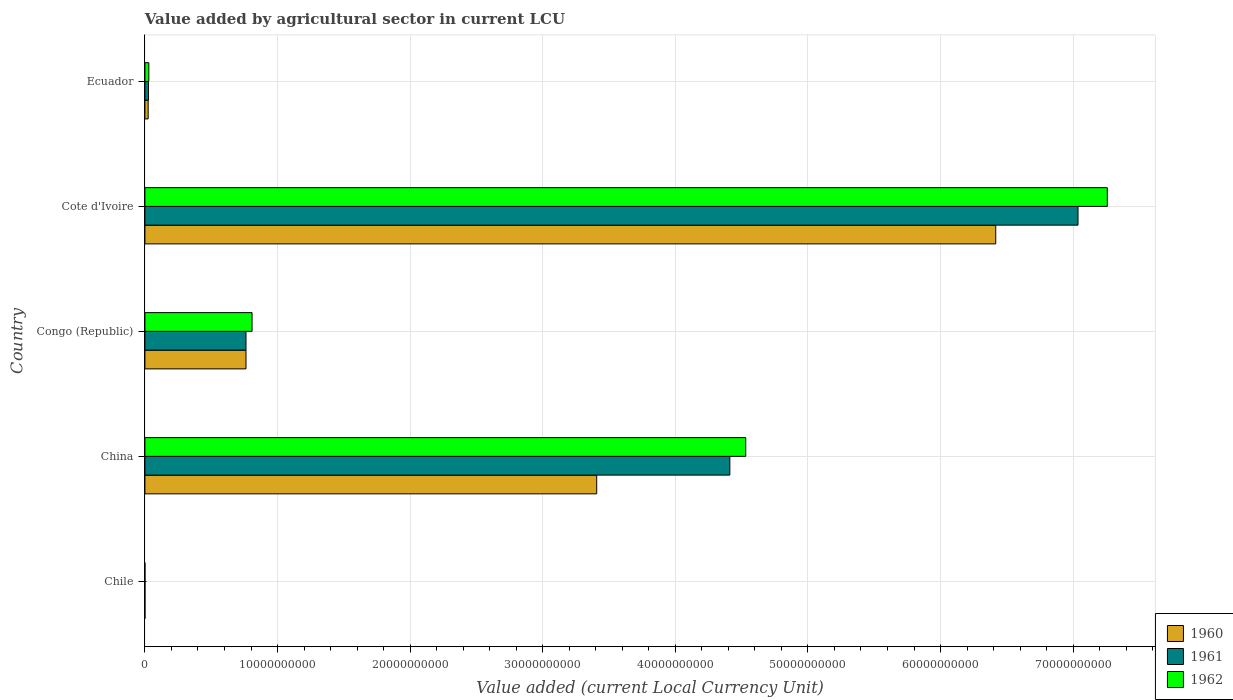How many groups of bars are there?
Your response must be concise. 5. Are the number of bars per tick equal to the number of legend labels?
Provide a short and direct response. Yes. Are the number of bars on each tick of the Y-axis equal?
Provide a short and direct response. Yes. How many bars are there on the 1st tick from the bottom?
Offer a terse response. 3. What is the label of the 2nd group of bars from the top?
Your answer should be very brief. Cote d'Ivoire. In how many cases, is the number of bars for a given country not equal to the number of legend labels?
Your response must be concise. 0. What is the value added by agricultural sector in 1962 in Cote d'Ivoire?
Your answer should be compact. 7.26e+1. Across all countries, what is the maximum value added by agricultural sector in 1961?
Your response must be concise. 7.04e+1. Across all countries, what is the minimum value added by agricultural sector in 1961?
Give a very brief answer. 5.00e+05. In which country was the value added by agricultural sector in 1961 maximum?
Provide a succinct answer. Cote d'Ivoire. What is the total value added by agricultural sector in 1962 in the graph?
Provide a short and direct response. 1.26e+11. What is the difference between the value added by agricultural sector in 1961 in Chile and that in China?
Make the answer very short. -4.41e+1. What is the difference between the value added by agricultural sector in 1961 in China and the value added by agricultural sector in 1960 in Congo (Republic)?
Your answer should be very brief. 3.65e+1. What is the average value added by agricultural sector in 1961 per country?
Provide a short and direct response. 2.45e+1. What is the difference between the value added by agricultural sector in 1961 and value added by agricultural sector in 1962 in China?
Ensure brevity in your answer.  -1.20e+09. What is the ratio of the value added by agricultural sector in 1960 in Chile to that in China?
Ensure brevity in your answer.  1.1740534194305841e-5. Is the value added by agricultural sector in 1962 in Cote d'Ivoire less than that in Ecuador?
Keep it short and to the point. No. Is the difference between the value added by agricultural sector in 1961 in Congo (Republic) and Ecuador greater than the difference between the value added by agricultural sector in 1962 in Congo (Republic) and Ecuador?
Your answer should be very brief. No. What is the difference between the highest and the second highest value added by agricultural sector in 1962?
Keep it short and to the point. 2.73e+1. What is the difference between the highest and the lowest value added by agricultural sector in 1962?
Offer a very short reply. 7.26e+1. Are all the bars in the graph horizontal?
Offer a terse response. Yes. How many countries are there in the graph?
Your response must be concise. 5. Are the values on the major ticks of X-axis written in scientific E-notation?
Provide a short and direct response. No. What is the title of the graph?
Your answer should be compact. Value added by agricultural sector in current LCU. Does "1998" appear as one of the legend labels in the graph?
Provide a succinct answer. No. What is the label or title of the X-axis?
Keep it short and to the point. Value added (current Local Currency Unit). What is the Value added (current Local Currency Unit) of 1960 in Chile?
Your answer should be very brief. 4.00e+05. What is the Value added (current Local Currency Unit) of 1962 in Chile?
Your answer should be very brief. 5.00e+05. What is the Value added (current Local Currency Unit) of 1960 in China?
Give a very brief answer. 3.41e+1. What is the Value added (current Local Currency Unit) in 1961 in China?
Keep it short and to the point. 4.41e+1. What is the Value added (current Local Currency Unit) of 1962 in China?
Make the answer very short. 4.53e+1. What is the Value added (current Local Currency Unit) of 1960 in Congo (Republic)?
Ensure brevity in your answer.  7.62e+09. What is the Value added (current Local Currency Unit) in 1961 in Congo (Republic)?
Your answer should be compact. 7.62e+09. What is the Value added (current Local Currency Unit) in 1962 in Congo (Republic)?
Keep it short and to the point. 8.08e+09. What is the Value added (current Local Currency Unit) in 1960 in Cote d'Ivoire?
Make the answer very short. 6.42e+1. What is the Value added (current Local Currency Unit) in 1961 in Cote d'Ivoire?
Provide a succinct answer. 7.04e+1. What is the Value added (current Local Currency Unit) in 1962 in Cote d'Ivoire?
Your answer should be compact. 7.26e+1. What is the Value added (current Local Currency Unit) of 1960 in Ecuador?
Keep it short and to the point. 2.45e+08. What is the Value added (current Local Currency Unit) of 1961 in Ecuador?
Offer a terse response. 2.66e+08. What is the Value added (current Local Currency Unit) in 1962 in Ecuador?
Offer a very short reply. 2.95e+08. Across all countries, what is the maximum Value added (current Local Currency Unit) of 1960?
Offer a terse response. 6.42e+1. Across all countries, what is the maximum Value added (current Local Currency Unit) in 1961?
Make the answer very short. 7.04e+1. Across all countries, what is the maximum Value added (current Local Currency Unit) in 1962?
Make the answer very short. 7.26e+1. Across all countries, what is the minimum Value added (current Local Currency Unit) in 1960?
Ensure brevity in your answer.  4.00e+05. What is the total Value added (current Local Currency Unit) in 1960 in the graph?
Provide a short and direct response. 1.06e+11. What is the total Value added (current Local Currency Unit) in 1961 in the graph?
Make the answer very short. 1.22e+11. What is the total Value added (current Local Currency Unit) in 1962 in the graph?
Your answer should be compact. 1.26e+11. What is the difference between the Value added (current Local Currency Unit) in 1960 in Chile and that in China?
Offer a terse response. -3.41e+1. What is the difference between the Value added (current Local Currency Unit) in 1961 in Chile and that in China?
Your answer should be very brief. -4.41e+1. What is the difference between the Value added (current Local Currency Unit) in 1962 in Chile and that in China?
Offer a terse response. -4.53e+1. What is the difference between the Value added (current Local Currency Unit) of 1960 in Chile and that in Congo (Republic)?
Give a very brief answer. -7.62e+09. What is the difference between the Value added (current Local Currency Unit) of 1961 in Chile and that in Congo (Republic)?
Offer a terse response. -7.62e+09. What is the difference between the Value added (current Local Currency Unit) of 1962 in Chile and that in Congo (Republic)?
Your answer should be very brief. -8.08e+09. What is the difference between the Value added (current Local Currency Unit) of 1960 in Chile and that in Cote d'Ivoire?
Make the answer very short. -6.42e+1. What is the difference between the Value added (current Local Currency Unit) in 1961 in Chile and that in Cote d'Ivoire?
Provide a succinct answer. -7.04e+1. What is the difference between the Value added (current Local Currency Unit) in 1962 in Chile and that in Cote d'Ivoire?
Your answer should be very brief. -7.26e+1. What is the difference between the Value added (current Local Currency Unit) in 1960 in Chile and that in Ecuador?
Provide a succinct answer. -2.45e+08. What is the difference between the Value added (current Local Currency Unit) of 1961 in Chile and that in Ecuador?
Make the answer very short. -2.66e+08. What is the difference between the Value added (current Local Currency Unit) of 1962 in Chile and that in Ecuador?
Ensure brevity in your answer.  -2.95e+08. What is the difference between the Value added (current Local Currency Unit) in 1960 in China and that in Congo (Republic)?
Provide a succinct answer. 2.64e+1. What is the difference between the Value added (current Local Currency Unit) of 1961 in China and that in Congo (Republic)?
Offer a terse response. 3.65e+1. What is the difference between the Value added (current Local Currency Unit) in 1962 in China and that in Congo (Republic)?
Your response must be concise. 3.72e+1. What is the difference between the Value added (current Local Currency Unit) in 1960 in China and that in Cote d'Ivoire?
Ensure brevity in your answer.  -3.01e+1. What is the difference between the Value added (current Local Currency Unit) of 1961 in China and that in Cote d'Ivoire?
Provide a short and direct response. -2.63e+1. What is the difference between the Value added (current Local Currency Unit) in 1962 in China and that in Cote d'Ivoire?
Your answer should be very brief. -2.73e+1. What is the difference between the Value added (current Local Currency Unit) of 1960 in China and that in Ecuador?
Provide a short and direct response. 3.38e+1. What is the difference between the Value added (current Local Currency Unit) in 1961 in China and that in Ecuador?
Make the answer very short. 4.38e+1. What is the difference between the Value added (current Local Currency Unit) in 1962 in China and that in Ecuador?
Provide a short and direct response. 4.50e+1. What is the difference between the Value added (current Local Currency Unit) in 1960 in Congo (Republic) and that in Cote d'Ivoire?
Your answer should be very brief. -5.65e+1. What is the difference between the Value added (current Local Currency Unit) in 1961 in Congo (Republic) and that in Cote d'Ivoire?
Offer a very short reply. -6.27e+1. What is the difference between the Value added (current Local Currency Unit) in 1962 in Congo (Republic) and that in Cote d'Ivoire?
Offer a terse response. -6.45e+1. What is the difference between the Value added (current Local Currency Unit) in 1960 in Congo (Republic) and that in Ecuador?
Provide a short and direct response. 7.38e+09. What is the difference between the Value added (current Local Currency Unit) in 1961 in Congo (Republic) and that in Ecuador?
Ensure brevity in your answer.  7.36e+09. What is the difference between the Value added (current Local Currency Unit) in 1962 in Congo (Republic) and that in Ecuador?
Provide a succinct answer. 7.79e+09. What is the difference between the Value added (current Local Currency Unit) of 1960 in Cote d'Ivoire and that in Ecuador?
Keep it short and to the point. 6.39e+1. What is the difference between the Value added (current Local Currency Unit) of 1961 in Cote d'Ivoire and that in Ecuador?
Make the answer very short. 7.01e+1. What is the difference between the Value added (current Local Currency Unit) in 1962 in Cote d'Ivoire and that in Ecuador?
Provide a succinct answer. 7.23e+1. What is the difference between the Value added (current Local Currency Unit) in 1960 in Chile and the Value added (current Local Currency Unit) in 1961 in China?
Provide a short and direct response. -4.41e+1. What is the difference between the Value added (current Local Currency Unit) of 1960 in Chile and the Value added (current Local Currency Unit) of 1962 in China?
Your answer should be compact. -4.53e+1. What is the difference between the Value added (current Local Currency Unit) of 1961 in Chile and the Value added (current Local Currency Unit) of 1962 in China?
Offer a terse response. -4.53e+1. What is the difference between the Value added (current Local Currency Unit) of 1960 in Chile and the Value added (current Local Currency Unit) of 1961 in Congo (Republic)?
Give a very brief answer. -7.62e+09. What is the difference between the Value added (current Local Currency Unit) of 1960 in Chile and the Value added (current Local Currency Unit) of 1962 in Congo (Republic)?
Keep it short and to the point. -8.08e+09. What is the difference between the Value added (current Local Currency Unit) in 1961 in Chile and the Value added (current Local Currency Unit) in 1962 in Congo (Republic)?
Ensure brevity in your answer.  -8.08e+09. What is the difference between the Value added (current Local Currency Unit) of 1960 in Chile and the Value added (current Local Currency Unit) of 1961 in Cote d'Ivoire?
Ensure brevity in your answer.  -7.04e+1. What is the difference between the Value added (current Local Currency Unit) in 1960 in Chile and the Value added (current Local Currency Unit) in 1962 in Cote d'Ivoire?
Ensure brevity in your answer.  -7.26e+1. What is the difference between the Value added (current Local Currency Unit) in 1961 in Chile and the Value added (current Local Currency Unit) in 1962 in Cote d'Ivoire?
Make the answer very short. -7.26e+1. What is the difference between the Value added (current Local Currency Unit) in 1960 in Chile and the Value added (current Local Currency Unit) in 1961 in Ecuador?
Your answer should be very brief. -2.66e+08. What is the difference between the Value added (current Local Currency Unit) of 1960 in Chile and the Value added (current Local Currency Unit) of 1962 in Ecuador?
Offer a terse response. -2.95e+08. What is the difference between the Value added (current Local Currency Unit) in 1961 in Chile and the Value added (current Local Currency Unit) in 1962 in Ecuador?
Keep it short and to the point. -2.95e+08. What is the difference between the Value added (current Local Currency Unit) of 1960 in China and the Value added (current Local Currency Unit) of 1961 in Congo (Republic)?
Your answer should be compact. 2.64e+1. What is the difference between the Value added (current Local Currency Unit) in 1960 in China and the Value added (current Local Currency Unit) in 1962 in Congo (Republic)?
Provide a short and direct response. 2.60e+1. What is the difference between the Value added (current Local Currency Unit) in 1961 in China and the Value added (current Local Currency Unit) in 1962 in Congo (Republic)?
Offer a terse response. 3.60e+1. What is the difference between the Value added (current Local Currency Unit) in 1960 in China and the Value added (current Local Currency Unit) in 1961 in Cote d'Ivoire?
Ensure brevity in your answer.  -3.63e+1. What is the difference between the Value added (current Local Currency Unit) in 1960 in China and the Value added (current Local Currency Unit) in 1962 in Cote d'Ivoire?
Give a very brief answer. -3.85e+1. What is the difference between the Value added (current Local Currency Unit) of 1961 in China and the Value added (current Local Currency Unit) of 1962 in Cote d'Ivoire?
Offer a terse response. -2.85e+1. What is the difference between the Value added (current Local Currency Unit) of 1960 in China and the Value added (current Local Currency Unit) of 1961 in Ecuador?
Keep it short and to the point. 3.38e+1. What is the difference between the Value added (current Local Currency Unit) in 1960 in China and the Value added (current Local Currency Unit) in 1962 in Ecuador?
Keep it short and to the point. 3.38e+1. What is the difference between the Value added (current Local Currency Unit) of 1961 in China and the Value added (current Local Currency Unit) of 1962 in Ecuador?
Provide a succinct answer. 4.38e+1. What is the difference between the Value added (current Local Currency Unit) in 1960 in Congo (Republic) and the Value added (current Local Currency Unit) in 1961 in Cote d'Ivoire?
Make the answer very short. -6.27e+1. What is the difference between the Value added (current Local Currency Unit) in 1960 in Congo (Republic) and the Value added (current Local Currency Unit) in 1962 in Cote d'Ivoire?
Ensure brevity in your answer.  -6.50e+1. What is the difference between the Value added (current Local Currency Unit) of 1961 in Congo (Republic) and the Value added (current Local Currency Unit) of 1962 in Cote d'Ivoire?
Offer a terse response. -6.50e+1. What is the difference between the Value added (current Local Currency Unit) of 1960 in Congo (Republic) and the Value added (current Local Currency Unit) of 1961 in Ecuador?
Your response must be concise. 7.36e+09. What is the difference between the Value added (current Local Currency Unit) of 1960 in Congo (Republic) and the Value added (current Local Currency Unit) of 1962 in Ecuador?
Keep it short and to the point. 7.33e+09. What is the difference between the Value added (current Local Currency Unit) in 1961 in Congo (Republic) and the Value added (current Local Currency Unit) in 1962 in Ecuador?
Offer a terse response. 7.33e+09. What is the difference between the Value added (current Local Currency Unit) in 1960 in Cote d'Ivoire and the Value added (current Local Currency Unit) in 1961 in Ecuador?
Your answer should be very brief. 6.39e+1. What is the difference between the Value added (current Local Currency Unit) in 1960 in Cote d'Ivoire and the Value added (current Local Currency Unit) in 1962 in Ecuador?
Keep it short and to the point. 6.39e+1. What is the difference between the Value added (current Local Currency Unit) in 1961 in Cote d'Ivoire and the Value added (current Local Currency Unit) in 1962 in Ecuador?
Your response must be concise. 7.01e+1. What is the average Value added (current Local Currency Unit) of 1960 per country?
Provide a short and direct response. 2.12e+1. What is the average Value added (current Local Currency Unit) of 1961 per country?
Give a very brief answer. 2.45e+1. What is the average Value added (current Local Currency Unit) of 1962 per country?
Ensure brevity in your answer.  2.53e+1. What is the difference between the Value added (current Local Currency Unit) of 1961 and Value added (current Local Currency Unit) of 1962 in Chile?
Your response must be concise. 0. What is the difference between the Value added (current Local Currency Unit) in 1960 and Value added (current Local Currency Unit) in 1961 in China?
Provide a succinct answer. -1.00e+1. What is the difference between the Value added (current Local Currency Unit) of 1960 and Value added (current Local Currency Unit) of 1962 in China?
Your response must be concise. -1.12e+1. What is the difference between the Value added (current Local Currency Unit) of 1961 and Value added (current Local Currency Unit) of 1962 in China?
Your answer should be compact. -1.20e+09. What is the difference between the Value added (current Local Currency Unit) in 1960 and Value added (current Local Currency Unit) in 1961 in Congo (Republic)?
Ensure brevity in your answer.  0. What is the difference between the Value added (current Local Currency Unit) in 1960 and Value added (current Local Currency Unit) in 1962 in Congo (Republic)?
Your answer should be compact. -4.57e+08. What is the difference between the Value added (current Local Currency Unit) of 1961 and Value added (current Local Currency Unit) of 1962 in Congo (Republic)?
Offer a terse response. -4.57e+08. What is the difference between the Value added (current Local Currency Unit) of 1960 and Value added (current Local Currency Unit) of 1961 in Cote d'Ivoire?
Ensure brevity in your answer.  -6.21e+09. What is the difference between the Value added (current Local Currency Unit) of 1960 and Value added (current Local Currency Unit) of 1962 in Cote d'Ivoire?
Offer a terse response. -8.41e+09. What is the difference between the Value added (current Local Currency Unit) in 1961 and Value added (current Local Currency Unit) in 1962 in Cote d'Ivoire?
Make the answer very short. -2.21e+09. What is the difference between the Value added (current Local Currency Unit) of 1960 and Value added (current Local Currency Unit) of 1961 in Ecuador?
Give a very brief answer. -2.09e+07. What is the difference between the Value added (current Local Currency Unit) of 1960 and Value added (current Local Currency Unit) of 1962 in Ecuador?
Provide a succinct answer. -4.98e+07. What is the difference between the Value added (current Local Currency Unit) in 1961 and Value added (current Local Currency Unit) in 1962 in Ecuador?
Provide a succinct answer. -2.89e+07. What is the ratio of the Value added (current Local Currency Unit) of 1960 in Chile to that in China?
Your answer should be very brief. 0. What is the ratio of the Value added (current Local Currency Unit) of 1962 in Chile to that in China?
Offer a terse response. 0. What is the ratio of the Value added (current Local Currency Unit) of 1962 in Chile to that in Congo (Republic)?
Your answer should be very brief. 0. What is the ratio of the Value added (current Local Currency Unit) of 1960 in Chile to that in Cote d'Ivoire?
Keep it short and to the point. 0. What is the ratio of the Value added (current Local Currency Unit) in 1960 in Chile to that in Ecuador?
Give a very brief answer. 0. What is the ratio of the Value added (current Local Currency Unit) in 1961 in Chile to that in Ecuador?
Provide a succinct answer. 0. What is the ratio of the Value added (current Local Currency Unit) in 1962 in Chile to that in Ecuador?
Give a very brief answer. 0. What is the ratio of the Value added (current Local Currency Unit) of 1960 in China to that in Congo (Republic)?
Your answer should be compact. 4.47. What is the ratio of the Value added (current Local Currency Unit) of 1961 in China to that in Congo (Republic)?
Your response must be concise. 5.79. What is the ratio of the Value added (current Local Currency Unit) in 1962 in China to that in Congo (Republic)?
Your answer should be very brief. 5.61. What is the ratio of the Value added (current Local Currency Unit) in 1960 in China to that in Cote d'Ivoire?
Offer a very short reply. 0.53. What is the ratio of the Value added (current Local Currency Unit) in 1961 in China to that in Cote d'Ivoire?
Offer a terse response. 0.63. What is the ratio of the Value added (current Local Currency Unit) of 1962 in China to that in Cote d'Ivoire?
Give a very brief answer. 0.62. What is the ratio of the Value added (current Local Currency Unit) in 1960 in China to that in Ecuador?
Make the answer very short. 138.9. What is the ratio of the Value added (current Local Currency Unit) in 1961 in China to that in Ecuador?
Give a very brief answer. 165.71. What is the ratio of the Value added (current Local Currency Unit) of 1962 in China to that in Ecuador?
Make the answer very short. 153.57. What is the ratio of the Value added (current Local Currency Unit) of 1960 in Congo (Republic) to that in Cote d'Ivoire?
Keep it short and to the point. 0.12. What is the ratio of the Value added (current Local Currency Unit) in 1961 in Congo (Republic) to that in Cote d'Ivoire?
Your response must be concise. 0.11. What is the ratio of the Value added (current Local Currency Unit) in 1962 in Congo (Republic) to that in Cote d'Ivoire?
Provide a succinct answer. 0.11. What is the ratio of the Value added (current Local Currency Unit) of 1960 in Congo (Republic) to that in Ecuador?
Offer a terse response. 31.08. What is the ratio of the Value added (current Local Currency Unit) of 1961 in Congo (Republic) to that in Ecuador?
Keep it short and to the point. 28.64. What is the ratio of the Value added (current Local Currency Unit) in 1962 in Congo (Republic) to that in Ecuador?
Provide a short and direct response. 27.39. What is the ratio of the Value added (current Local Currency Unit) in 1960 in Cote d'Ivoire to that in Ecuador?
Provide a short and direct response. 261.58. What is the ratio of the Value added (current Local Currency Unit) of 1961 in Cote d'Ivoire to that in Ecuador?
Give a very brief answer. 264.35. What is the ratio of the Value added (current Local Currency Unit) of 1962 in Cote d'Ivoire to that in Ecuador?
Your answer should be very brief. 245.99. What is the difference between the highest and the second highest Value added (current Local Currency Unit) of 1960?
Your answer should be very brief. 3.01e+1. What is the difference between the highest and the second highest Value added (current Local Currency Unit) of 1961?
Your answer should be compact. 2.63e+1. What is the difference between the highest and the second highest Value added (current Local Currency Unit) of 1962?
Offer a terse response. 2.73e+1. What is the difference between the highest and the lowest Value added (current Local Currency Unit) in 1960?
Provide a succinct answer. 6.42e+1. What is the difference between the highest and the lowest Value added (current Local Currency Unit) of 1961?
Offer a terse response. 7.04e+1. What is the difference between the highest and the lowest Value added (current Local Currency Unit) of 1962?
Your answer should be very brief. 7.26e+1. 